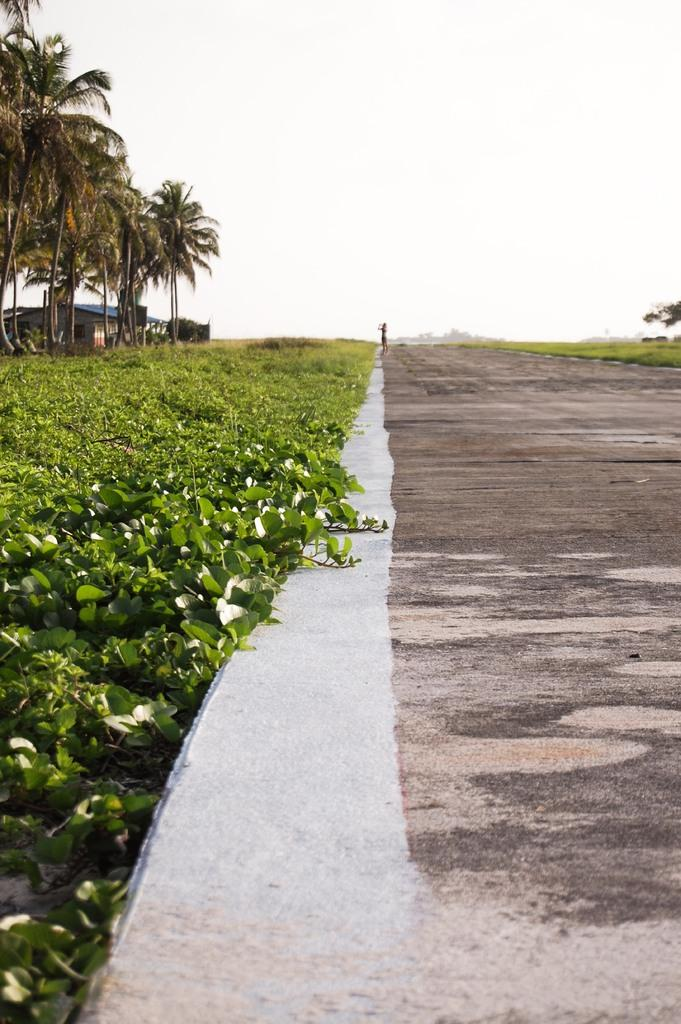What can be seen on the right side of the image? There is a path on the right side of the image. What is located on the left side of the image? There are plants and trees on the left side of the image. What color is the background of the image? The background of the image is white. Can you see the mother wearing a mask in the image? There is no mother or mask present in the image. What type of form is visible in the image? The image does not depict any specific form; it shows a path, plants, trees, and a white background. 